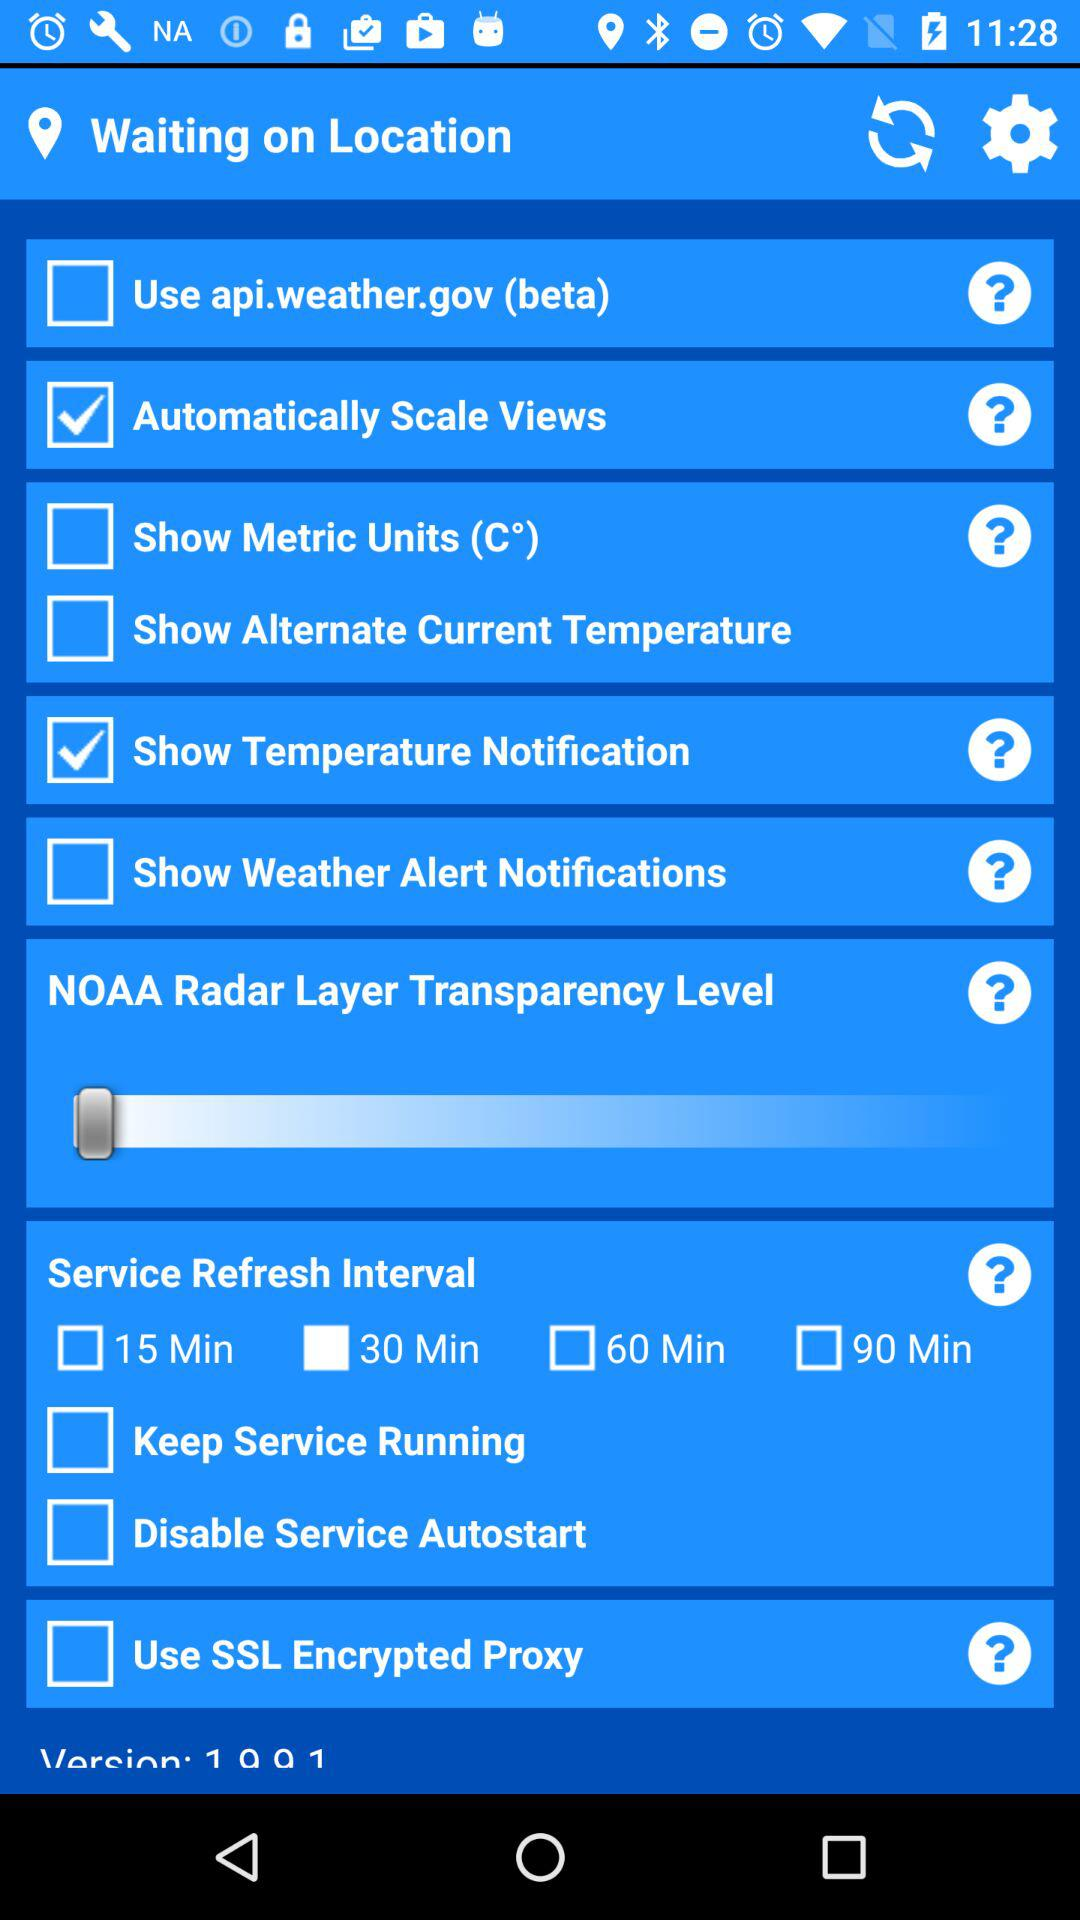What settings are checked? The checked settings are "Automatically Scale Views" and "Show Temperature Notification". 